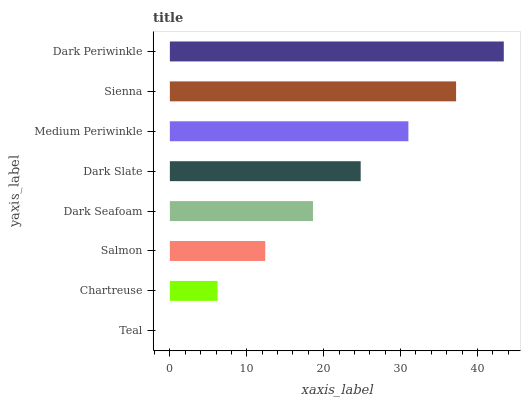Is Teal the minimum?
Answer yes or no. Yes. Is Dark Periwinkle the maximum?
Answer yes or no. Yes. Is Chartreuse the minimum?
Answer yes or no. No. Is Chartreuse the maximum?
Answer yes or no. No. Is Chartreuse greater than Teal?
Answer yes or no. Yes. Is Teal less than Chartreuse?
Answer yes or no. Yes. Is Teal greater than Chartreuse?
Answer yes or no. No. Is Chartreuse less than Teal?
Answer yes or no. No. Is Dark Slate the high median?
Answer yes or no. Yes. Is Dark Seafoam the low median?
Answer yes or no. Yes. Is Dark Periwinkle the high median?
Answer yes or no. No. Is Medium Periwinkle the low median?
Answer yes or no. No. 